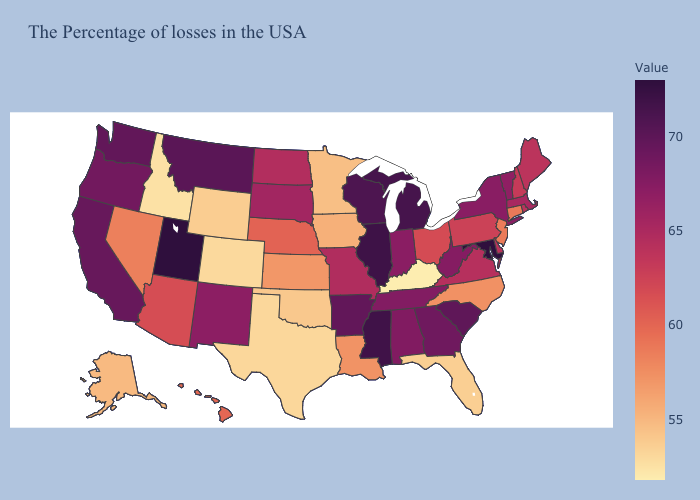Is the legend a continuous bar?
Keep it brief. Yes. Does Kentucky have the lowest value in the USA?
Keep it brief. Yes. Does Maryland have the highest value in the USA?
Concise answer only. Yes. Is the legend a continuous bar?
Quick response, please. Yes. Does New Jersey have the highest value in the Northeast?
Be succinct. No. Does Pennsylvania have a lower value than West Virginia?
Give a very brief answer. Yes. Does Kentucky have the lowest value in the South?
Short answer required. Yes. 